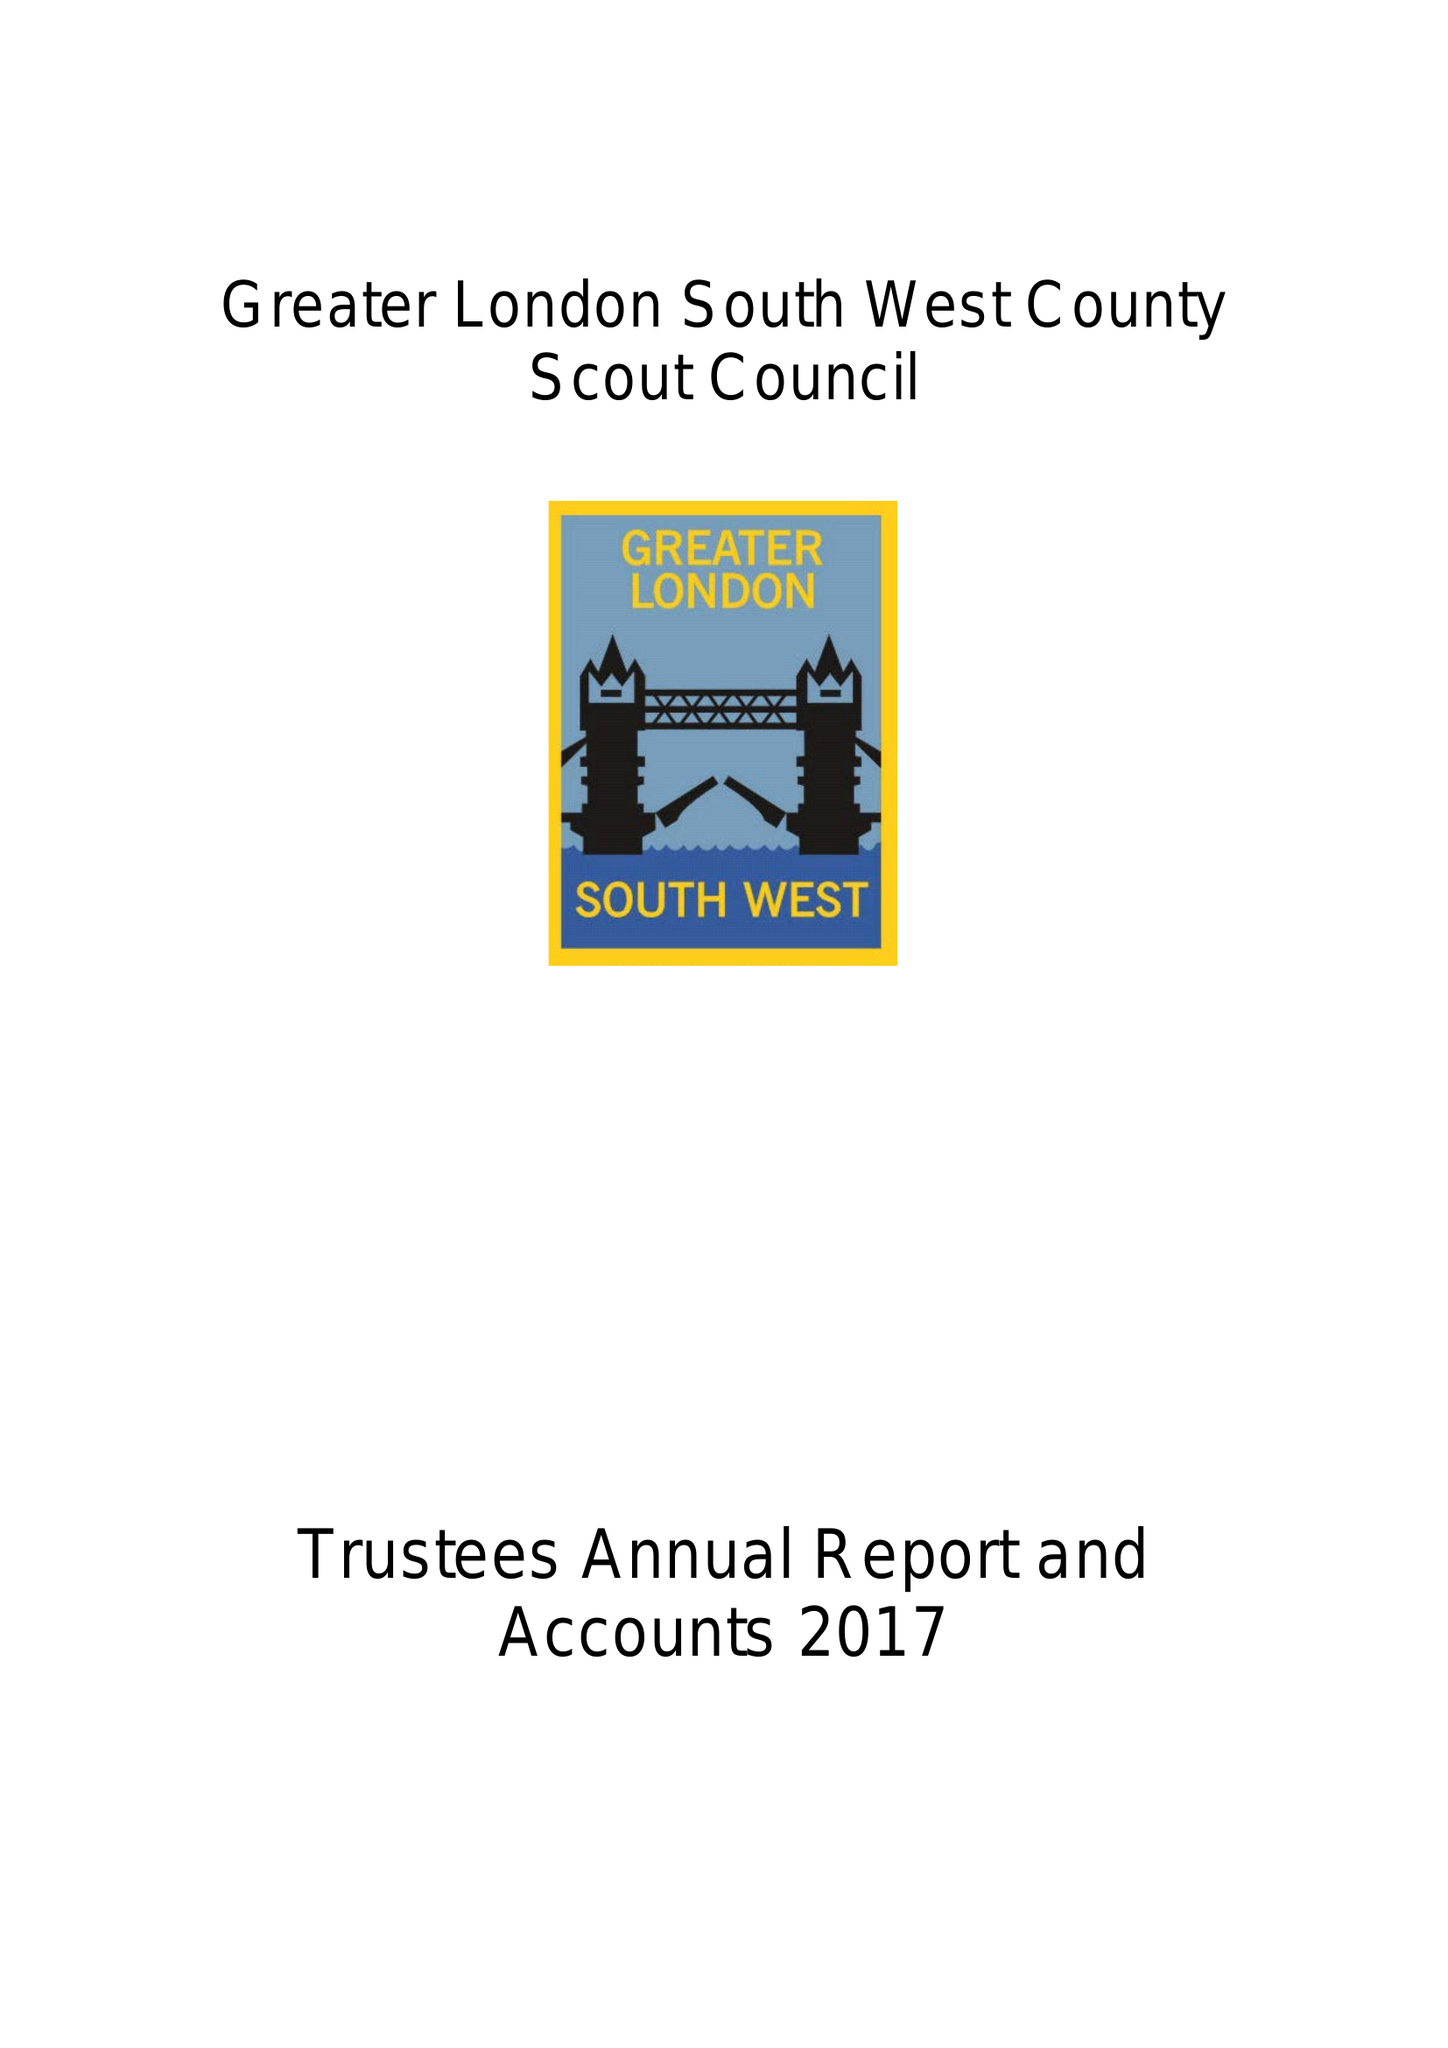What is the value for the address__post_town?
Answer the question using a single word or phrase. WORCESTER PARK 